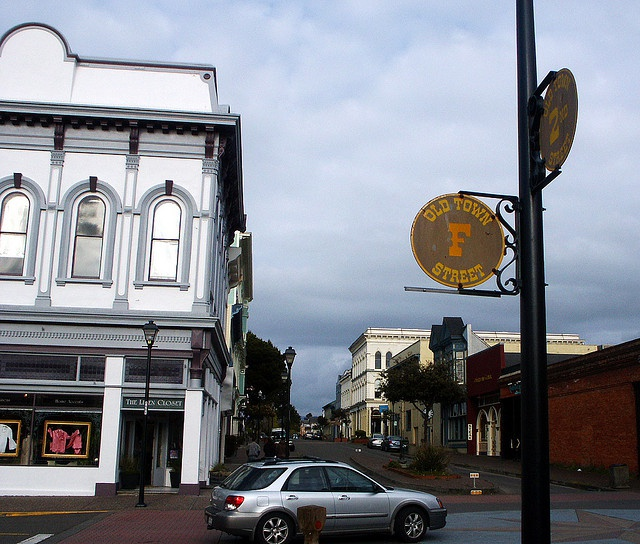Describe the objects in this image and their specific colors. I can see car in lightblue, black, gray, lightgray, and darkgray tones, car in lightblue, black, gray, purple, and darkgray tones, people in lightblue, black, and gray tones, car in lightblue, black, gray, lightgray, and darkgray tones, and people in black, gray, and lightblue tones in this image. 